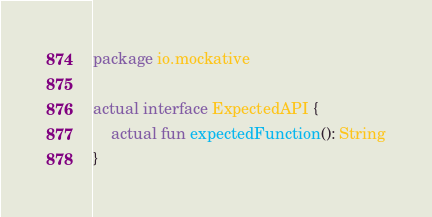<code> <loc_0><loc_0><loc_500><loc_500><_Kotlin_>package io.mockative

actual interface ExpectedAPI {
    actual fun expectedFunction(): String
}
</code> 